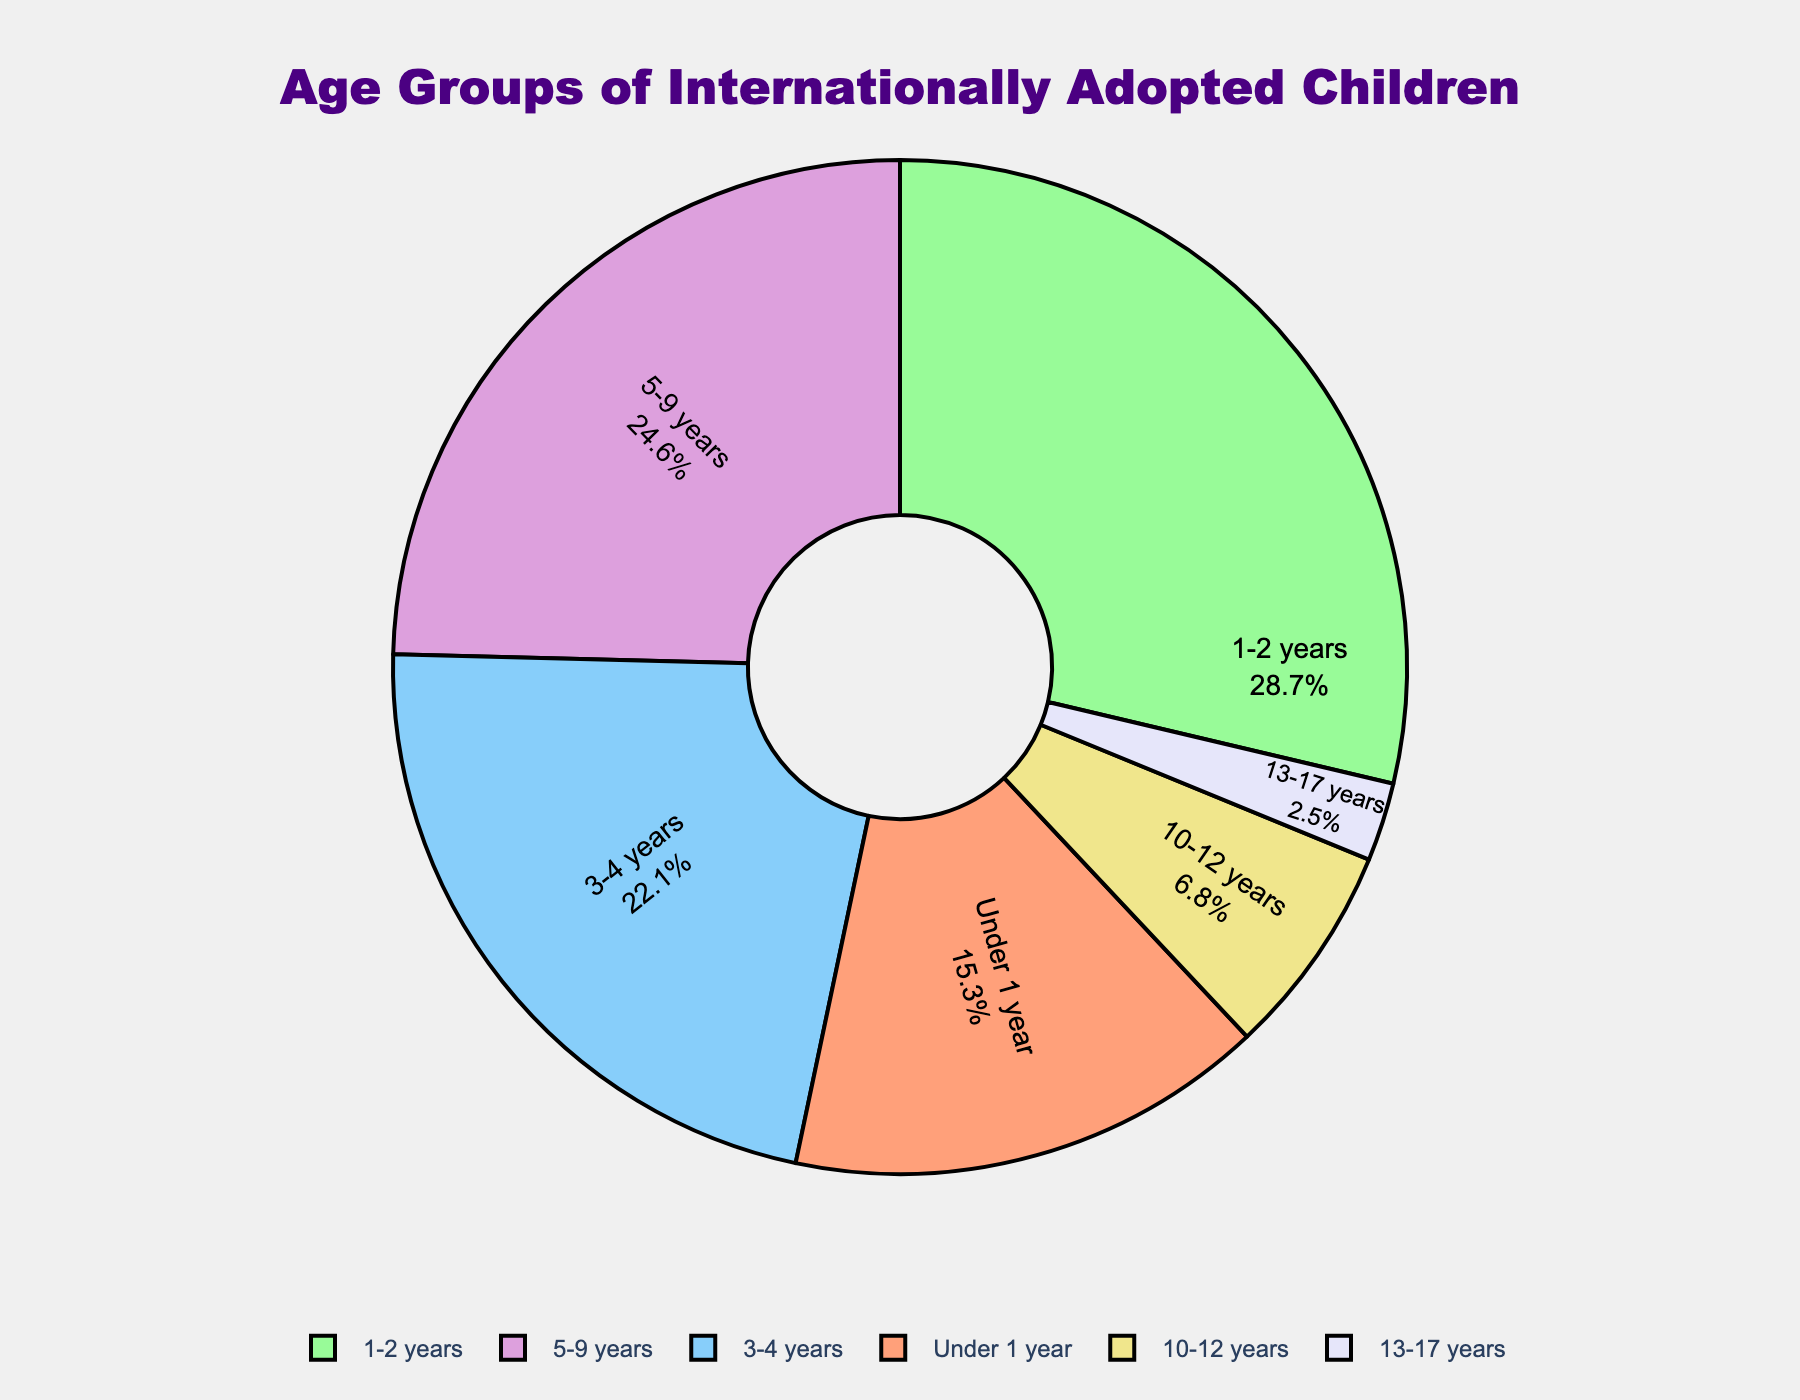Which age group has the highest percentage of internationally adopted children? The figure shows the breakdown of percentages for each age group, and the highest value is the 1-2 years group.
Answer: 1-2 years What is the total percentage of internationally adopted children under 5 years of age? Add the percentages of the age groups 'Under 1 year', '1-2 years', and '3-4 years': 15.3% + 28.7% + 22.1% = 66.1%.
Answer: 66.1% How does the percentage of children aged 5-9 years compare to that of children aged 10-12 years? The figure shows 24.6% for the age group 5-9 years and 6.8% for the age group 10-12 years. 24.6% is greater than 6.8%.
Answer: 5-9 years is greater Which age group has the lowest percentage of internationally adopted children? The figure shows the percentages for each age group and the lowest value is for the 13-17 years group.
Answer: 13-17 years What is the combined percentage of internationally adopted children aged 3-4 years and 5-9 years? Add the percentages of the age groups '3-4 years' and '5-9 years': 22.1% + 24.6% = 46.7%.
Answer: 46.7% What percentage of internationally adopted children are 10 years or older? Sum the percentages of the age groups '10-12 years' and '13-17 years': 6.8% + 2.5% = 9.3%.
Answer: 9.3% How much larger is the percentage of children aged 1-2 years compared to children aged 13-17 years? Subtract the percentage of the '13-17 years' group from the '1-2 years' group: 28.7% - 2.5% = 26.2%.
Answer: 26.2% Which age group has a percentage closest to a quarter of the total? The figure shows that the 5-9 years age group has a percentage of 24.6%, which is closest to 25%.
Answer: 5-9 years Among the age groups, which has the second-highest percentage of internationally adopted children? The figure shows that the '5-9 years' age group has the second-highest percentage at 24.6%, following the '1-2 years' at 28.7%.
Answer: 5-9 years What is the difference in percentage between children under 1 year and those aged 3-4 years? Subtract the percentage of the 'Under 1 year' group from the '3-4 years' group: 22.1% - 15.3% = 6.8%.
Answer: 6.8% 